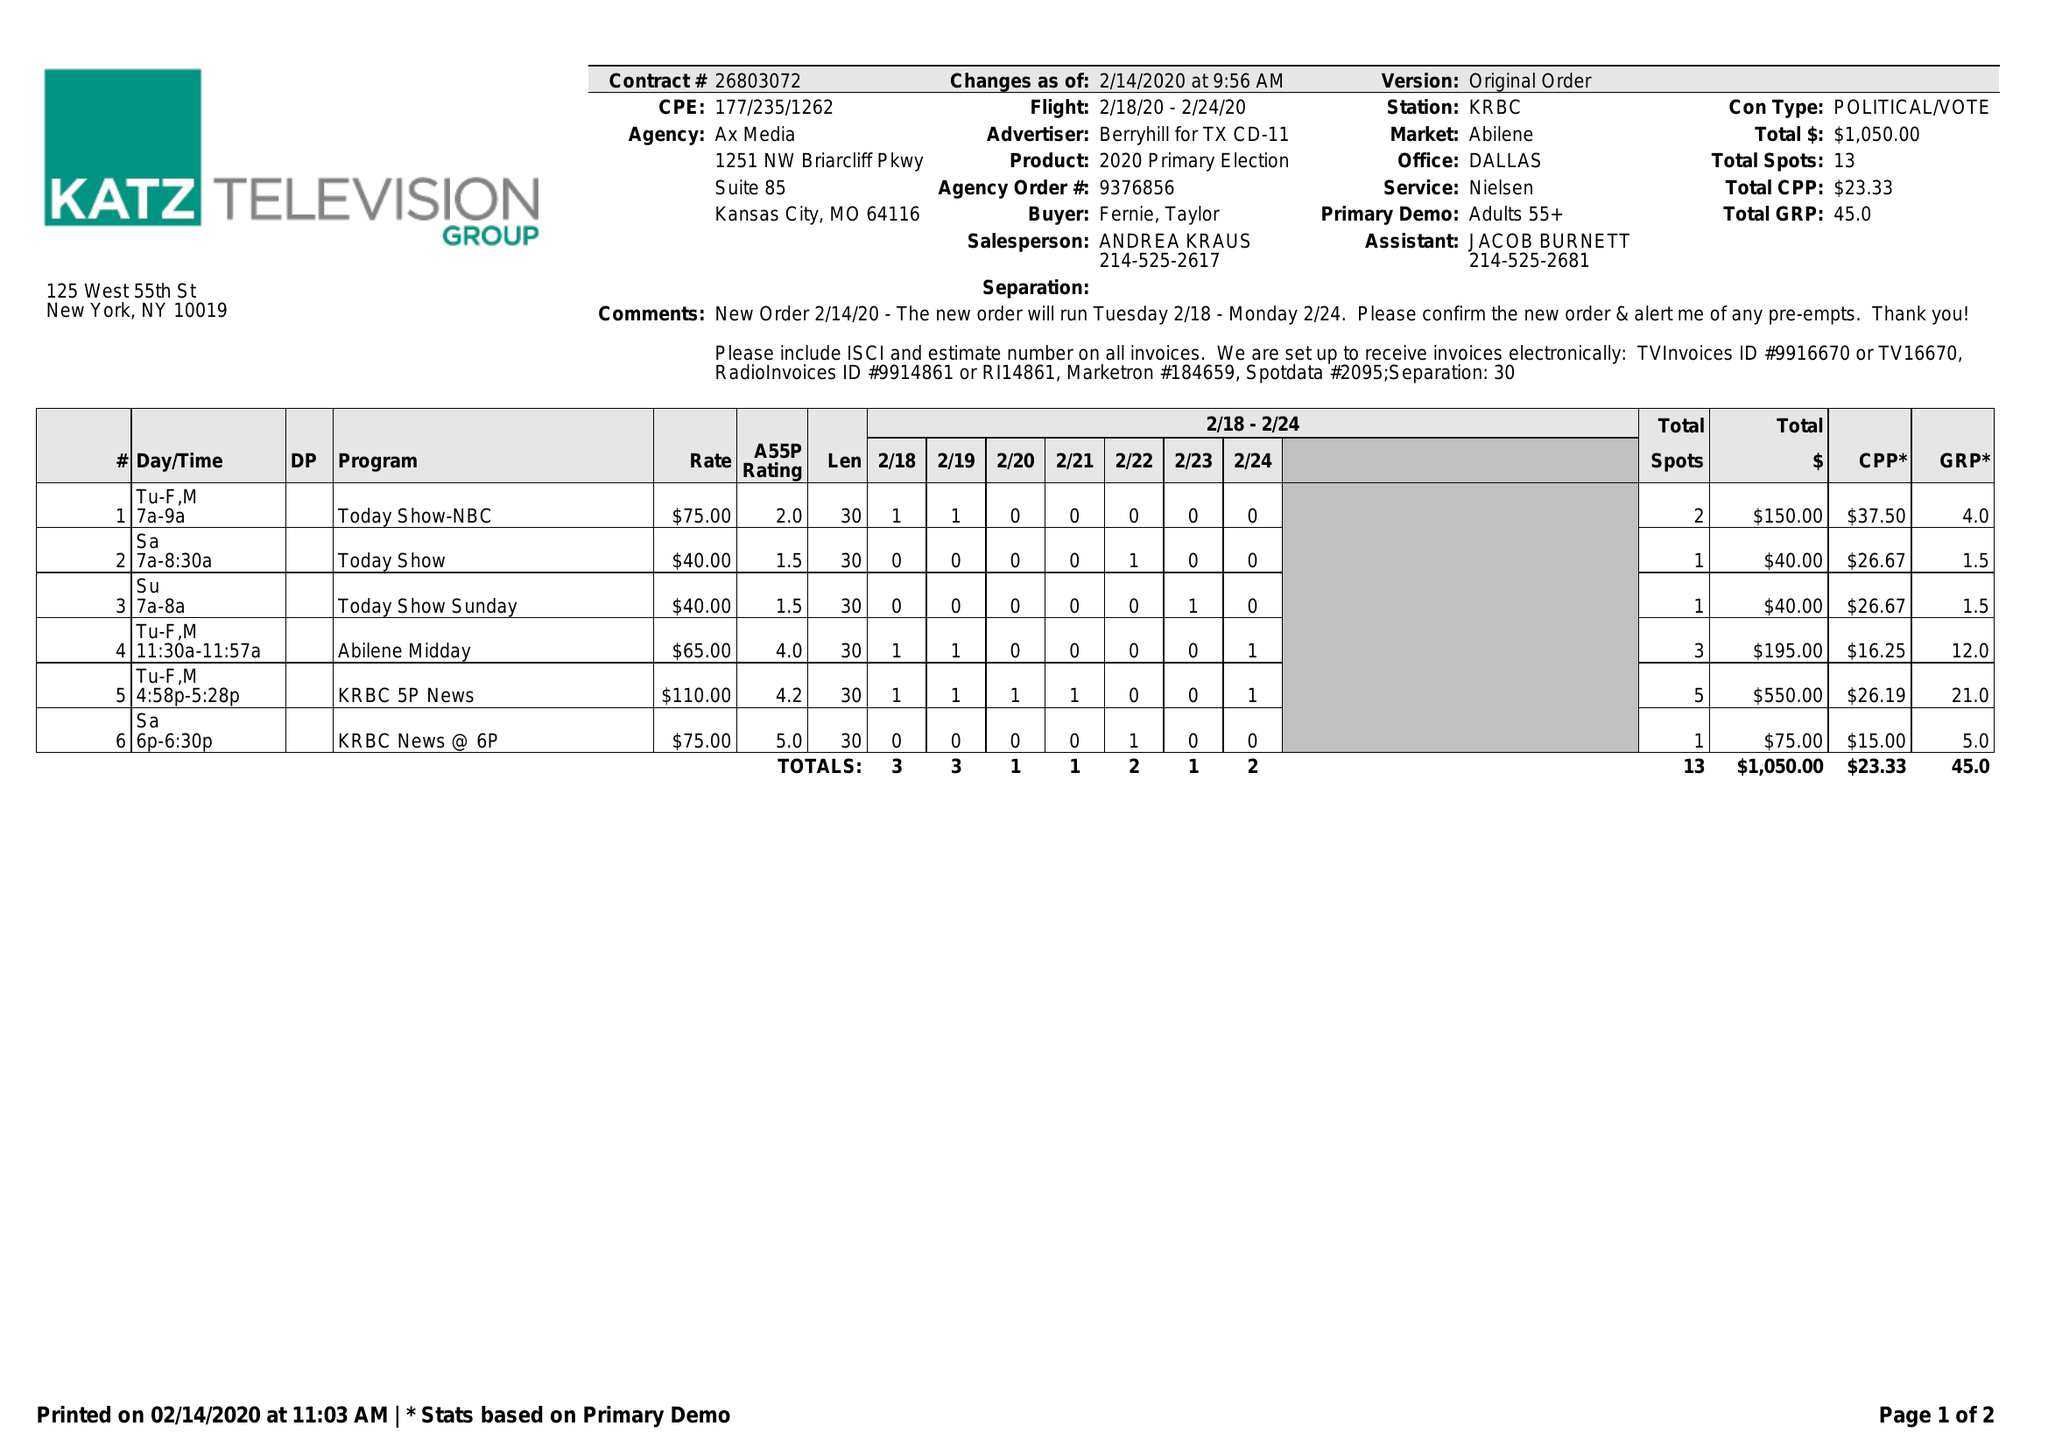What is the value for the gross_amount?
Answer the question using a single word or phrase. 1050.00 